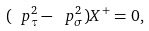Convert formula to latex. <formula><loc_0><loc_0><loc_500><loc_500>( \ p _ { \tau } ^ { 2 } - \ p _ { \sigma } ^ { 2 } ) X ^ { + } = 0 ,</formula> 